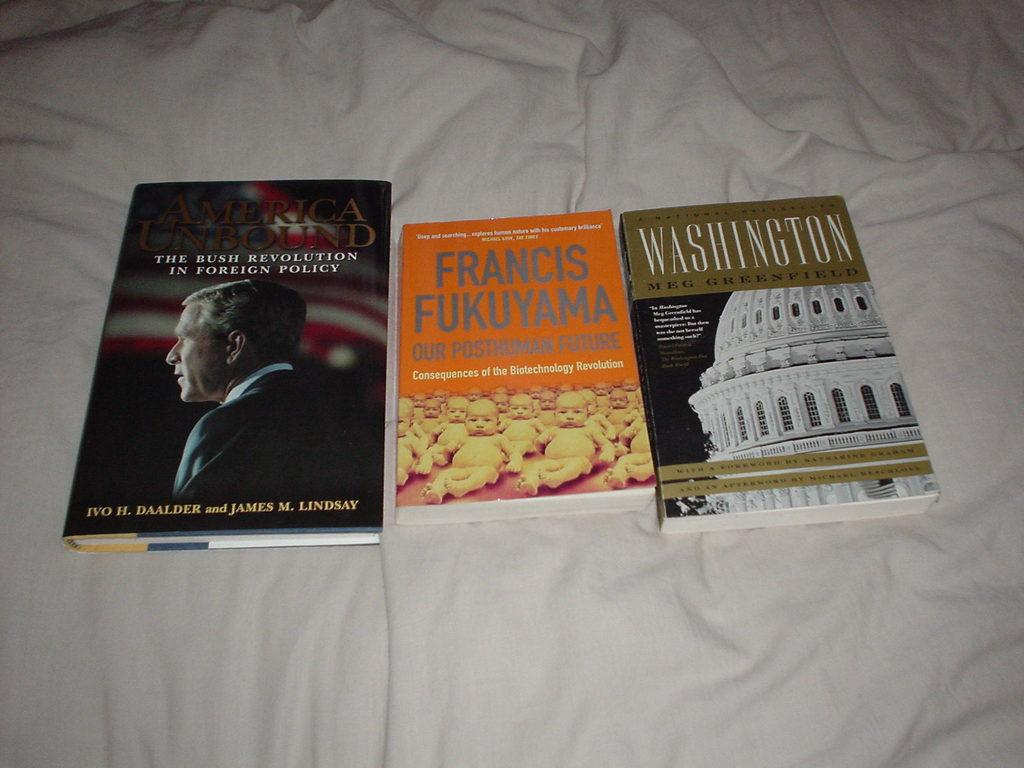Provide a one-sentence caption for the provided image. A book by Meg Greenfield is next to two other books. 